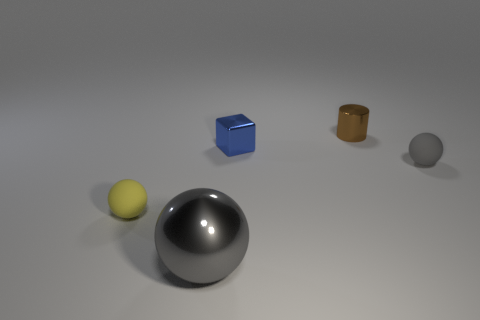How many tiny yellow balls are behind the gray object that is in front of the small rubber thing on the left side of the small cylinder?
Ensure brevity in your answer.  1. Do the small matte ball that is left of the tiny brown object and the small rubber ball that is on the right side of the tiny yellow object have the same color?
Ensure brevity in your answer.  No. What is the color of the shiny object that is in front of the brown cylinder and to the right of the large metallic object?
Ensure brevity in your answer.  Blue. What number of other green cylinders are the same size as the metal cylinder?
Your answer should be very brief. 0. What shape is the gray object right of the gray thing in front of the tiny gray matte sphere?
Offer a terse response. Sphere. What is the shape of the gray thing right of the gray object that is to the left of the ball that is right of the large metallic thing?
Give a very brief answer. Sphere. How many gray metal objects have the same shape as the gray rubber object?
Offer a terse response. 1. How many gray rubber things are left of the matte ball right of the small brown metallic object?
Give a very brief answer. 0. What number of shiny objects are either small cubes or balls?
Ensure brevity in your answer.  2. Are there any yellow things made of the same material as the yellow sphere?
Your answer should be compact. No. 